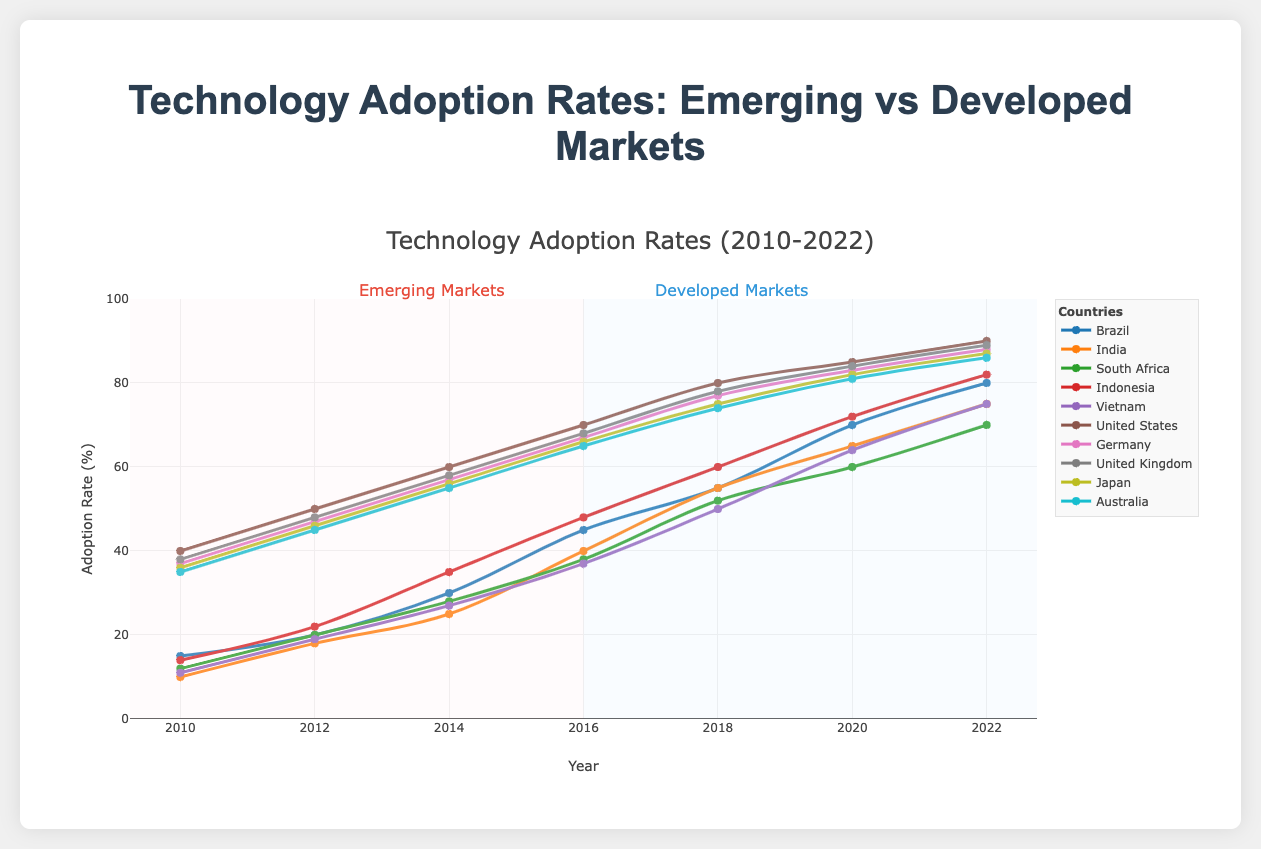Which country has the highest adoption rate in 2022 among emerging markets? By looking at the end points of the lines representing adoption rates for emerging markets in the plot for the year 2022, Indonesia has the highest rate at 82%.
Answer: Indonesia How did the adoption rate in India change from 2010 to 2022? The adoption rate in India increased from 10% in 2010 to 75% in 2022. The difference can be calculated as 75% - 10% = 65%.
Answer: It increased by 65% Which developed market had the slowest rate of increase in technology adoption between 2010 and 2022? By comparing the beginning and end points of the lines for developed markets, Australia had an increase from 35% to 86%, which is the smallest increase, calculated as 86% - 35% = 51%.
Answer: Australia Compare the adoption rate in Brazil and South Africa in 2016. Which country had a higher adoption rate? The adoption rates for 2016 are visible in the middle section of the plot. Brazil had a rate of 45% while South Africa had a rate of 38%, making Brazil's adoption rate higher.
Answer: Brazil What is the average adoption rate in Vietnam from 2010 to 2022? To find the average, sum the adoption rates for Vietnam: 11 + 19 + 27 + 37 + 50 + 64 + 75 = 283. Then, divide by the number of data points: 283 / 7 = 40.42%.
Answer: 40.42% Which country had the most significant increase in adoption rate from 2010 to 2022 within developed markets? By looking at the difference between the starting and ending points of the lines for developed markets, the United States had the largest increase from 40% to 90%, with an increment of 50%.
Answer: United States How much did the adoption rate in Germany change between 2014 and 2018? From 2014 to 2018, Germany's adoption rate moved from 57% to 77%. The change is calculated as 77% - 57% = 20%.
Answer: 20% In 2020, which country had a higher adoption rate: Brazil or India? Comparing the adoption rates for 2020, Brazil had an adoption rate of 70%, while India had an adoption rate of 65%. Therefore, Brazil's rate was higher.
Answer: Brazil 